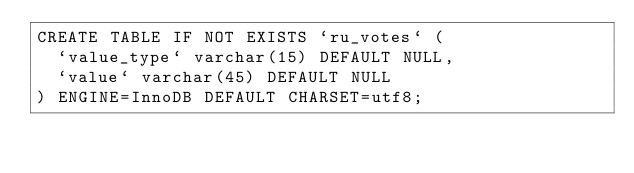<code> <loc_0><loc_0><loc_500><loc_500><_SQL_>CREATE TABLE IF NOT EXISTS `ru_votes` (
  `value_type` varchar(15) DEFAULT NULL,
  `value` varchar(45) DEFAULT NULL
) ENGINE=InnoDB DEFAULT CHARSET=utf8;</code> 